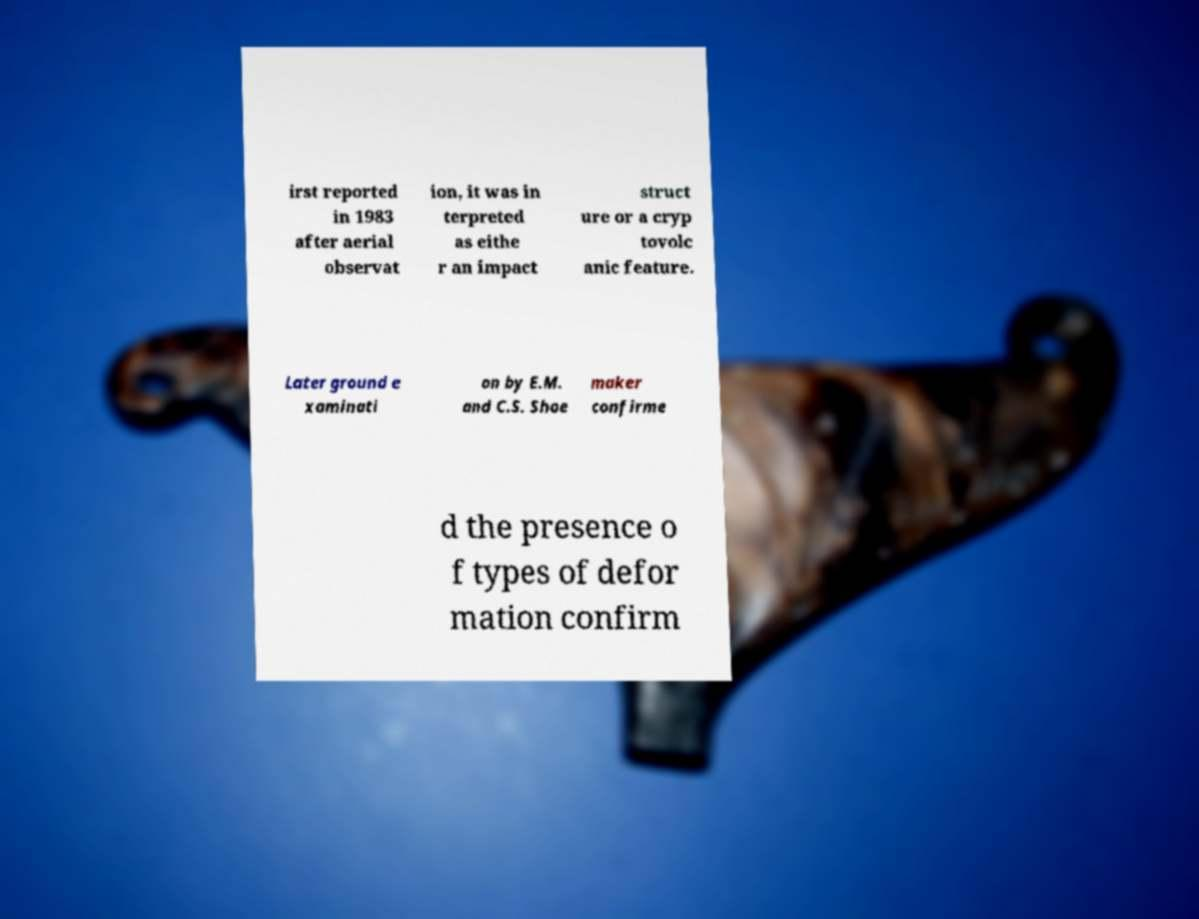Can you read and provide the text displayed in the image?This photo seems to have some interesting text. Can you extract and type it out for me? irst reported in 1983 after aerial observat ion, it was in terpreted as eithe r an impact struct ure or a cryp tovolc anic feature. Later ground e xaminati on by E.M. and C.S. Shoe maker confirme d the presence o f types of defor mation confirm 